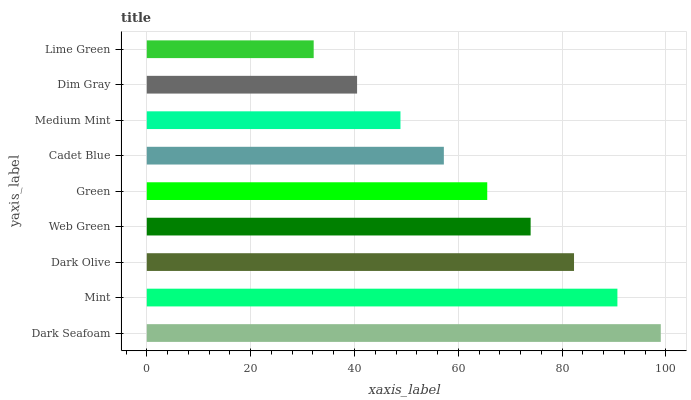Is Lime Green the minimum?
Answer yes or no. Yes. Is Dark Seafoam the maximum?
Answer yes or no. Yes. Is Mint the minimum?
Answer yes or no. No. Is Mint the maximum?
Answer yes or no. No. Is Dark Seafoam greater than Mint?
Answer yes or no. Yes. Is Mint less than Dark Seafoam?
Answer yes or no. Yes. Is Mint greater than Dark Seafoam?
Answer yes or no. No. Is Dark Seafoam less than Mint?
Answer yes or no. No. Is Green the high median?
Answer yes or no. Yes. Is Green the low median?
Answer yes or no. Yes. Is Dark Olive the high median?
Answer yes or no. No. Is Dark Olive the low median?
Answer yes or no. No. 